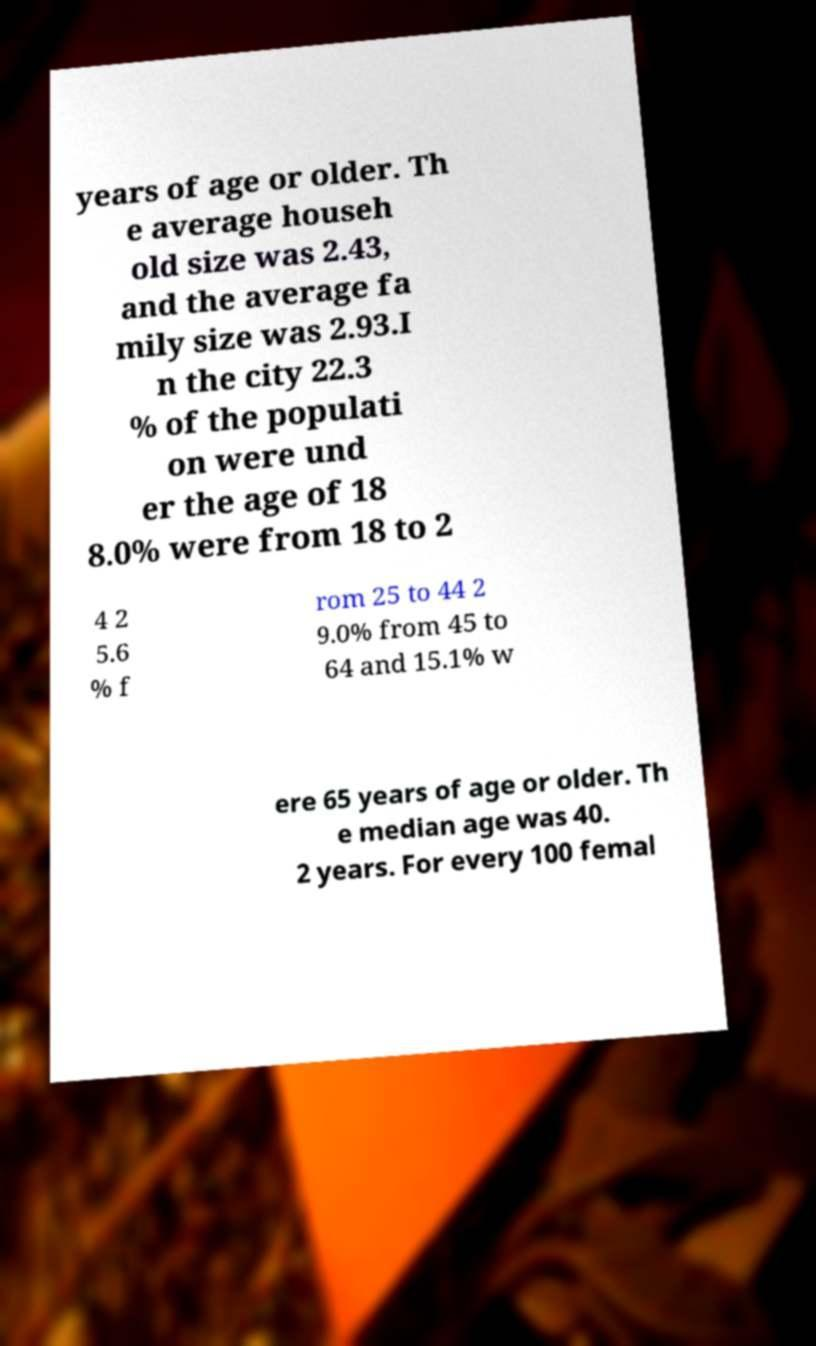There's text embedded in this image that I need extracted. Can you transcribe it verbatim? years of age or older. Th e average househ old size was 2.43, and the average fa mily size was 2.93.I n the city 22.3 % of the populati on were und er the age of 18 8.0% were from 18 to 2 4 2 5.6 % f rom 25 to 44 2 9.0% from 45 to 64 and 15.1% w ere 65 years of age or older. Th e median age was 40. 2 years. For every 100 femal 